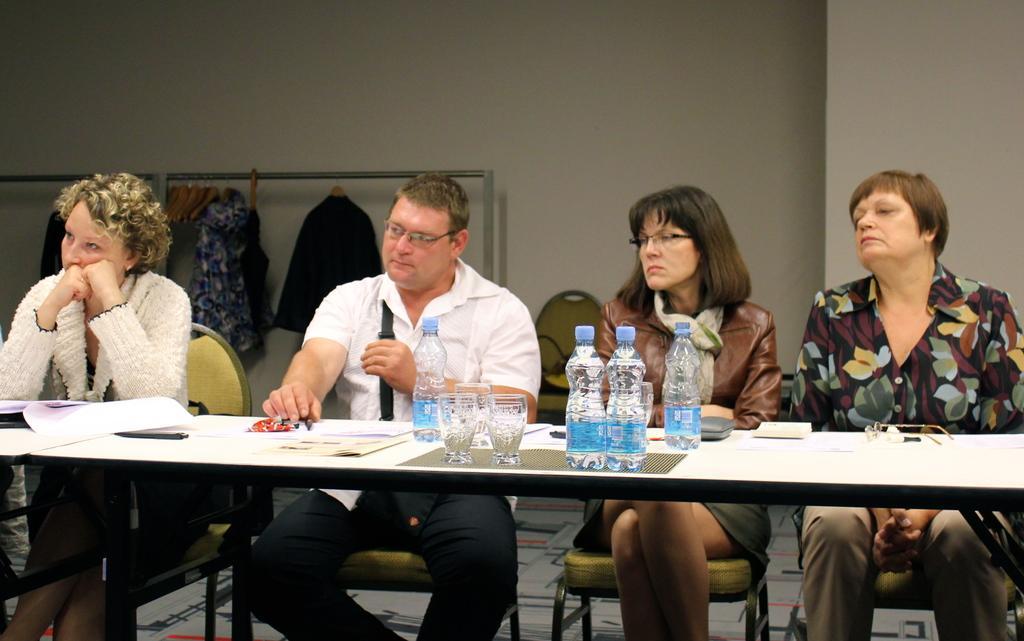Can you describe this image briefly? In this image there are three women sitting on the chair. At the middle of the image a person is sitting on the chair before a table having bottles and glasses and some papers on it. Backside to him there are few hangers. Few clothes are hanged to the hanger. Background there is a wall. 